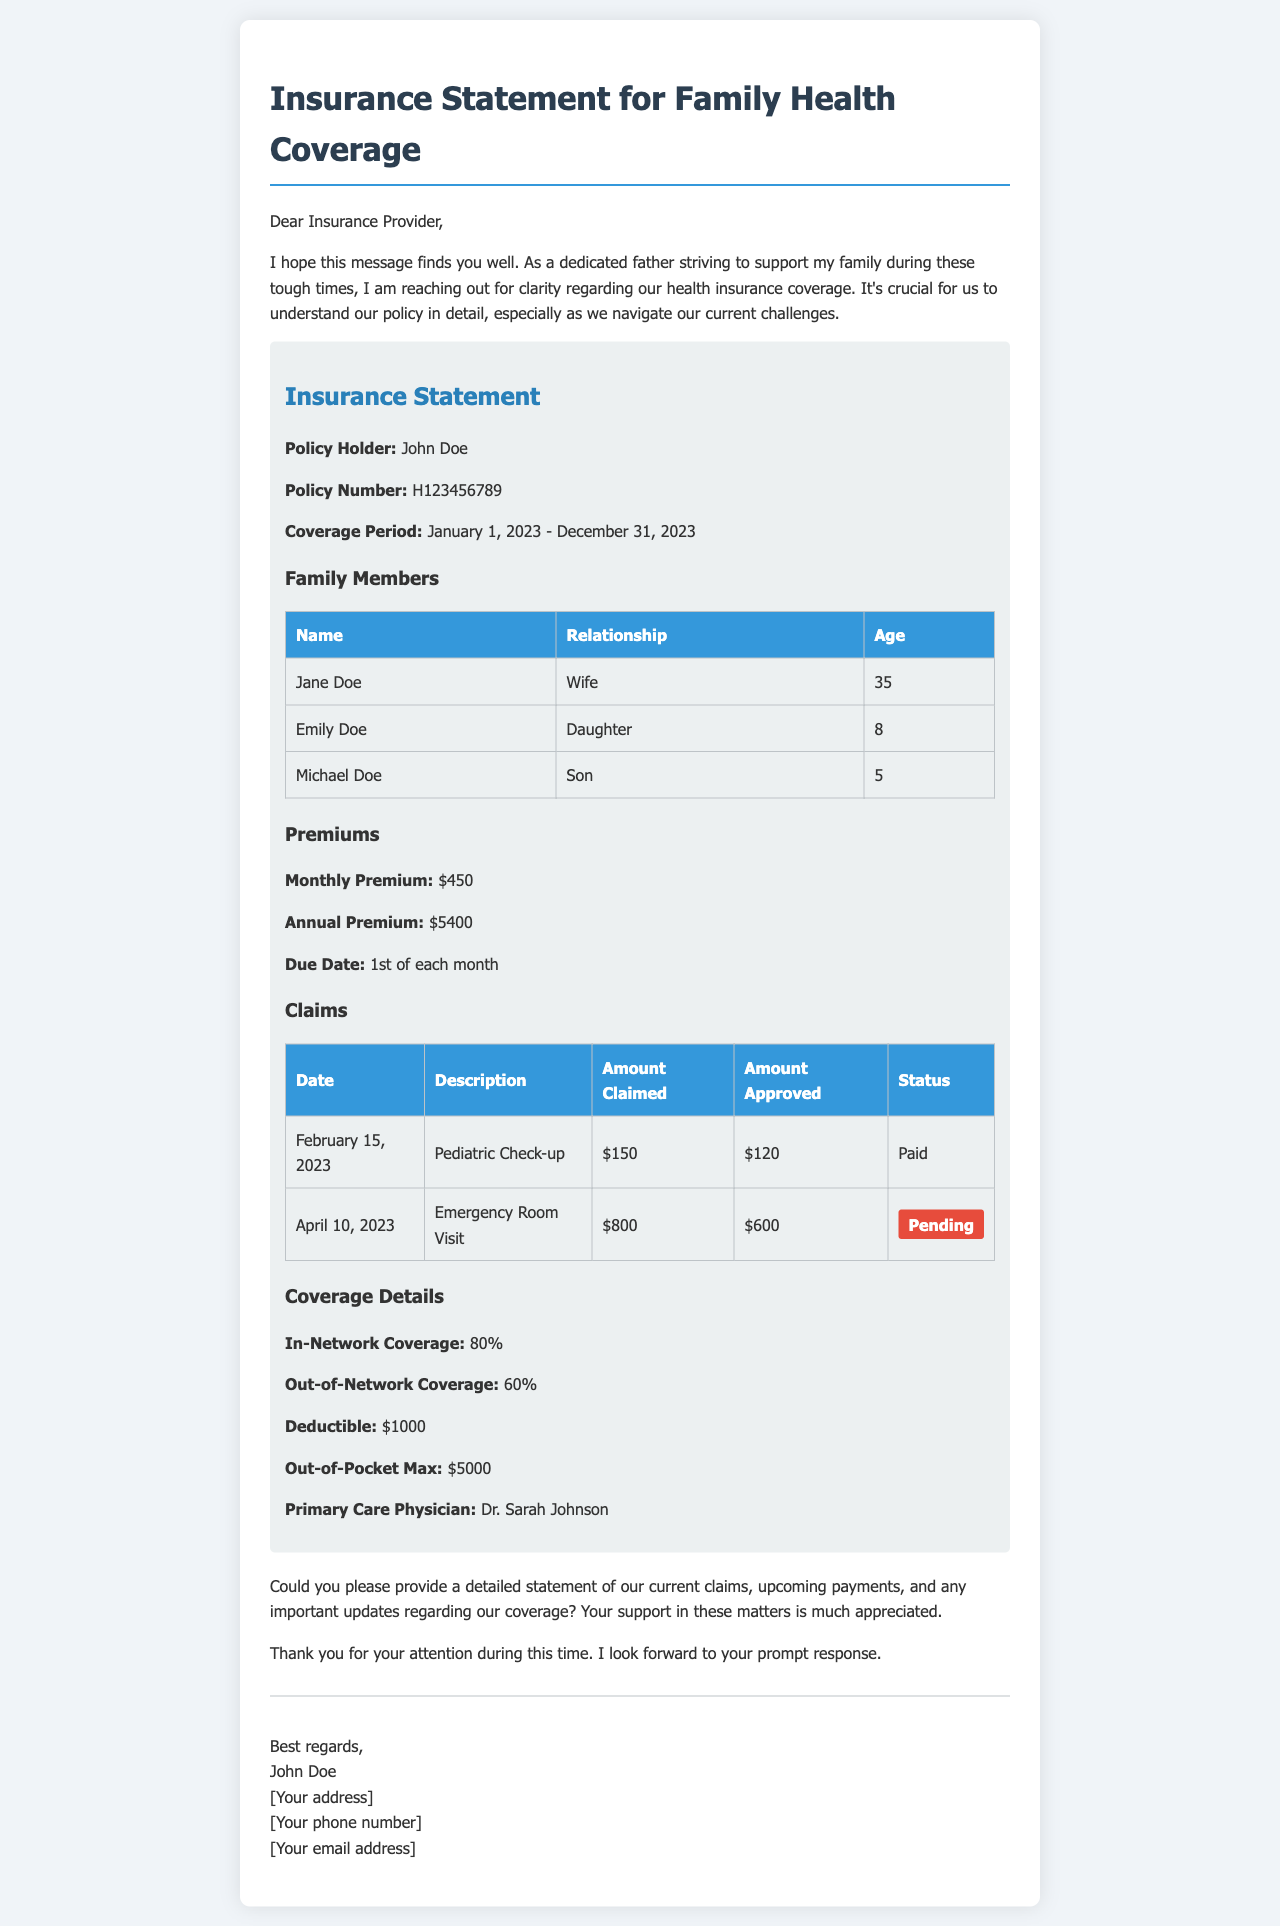What is the policy holder's name? The policy holder's name is stated in the insurance statement section of the document.
Answer: John Doe What is the monthly premium? The monthly premium is specifically listed under the premiums section of the document.
Answer: $450 What is the coverage period? The coverage period is indicated in the insurance statement section of the document.
Answer: January 1, 2023 - December 31, 2023 How much was claimed for the Emergency Room Visit? The amount claimed for the Emergency Room Visit can be found in the claims table of the document.
Answer: $800 What is the deductible amount? The deductible amount is outlined in the coverage details section of the document.
Answer: $1000 What is the status of the claim from April 10, 2023? The status of the claim is noted in the claims table and indicates the current progression of that specific claim.
Answer: Pending How many family members are listed? The number of family members can be counted from the family members table found in the document.
Answer: 3 What is the name of the primary care physician? The name of the primary care physician is mentioned in the coverage details section.
Answer: Dr. Sarah Johnson What are the out-of-pocket maximum expenses? The out-of-pocket maximum is specified within the coverage details section of the document.
Answer: $5000 